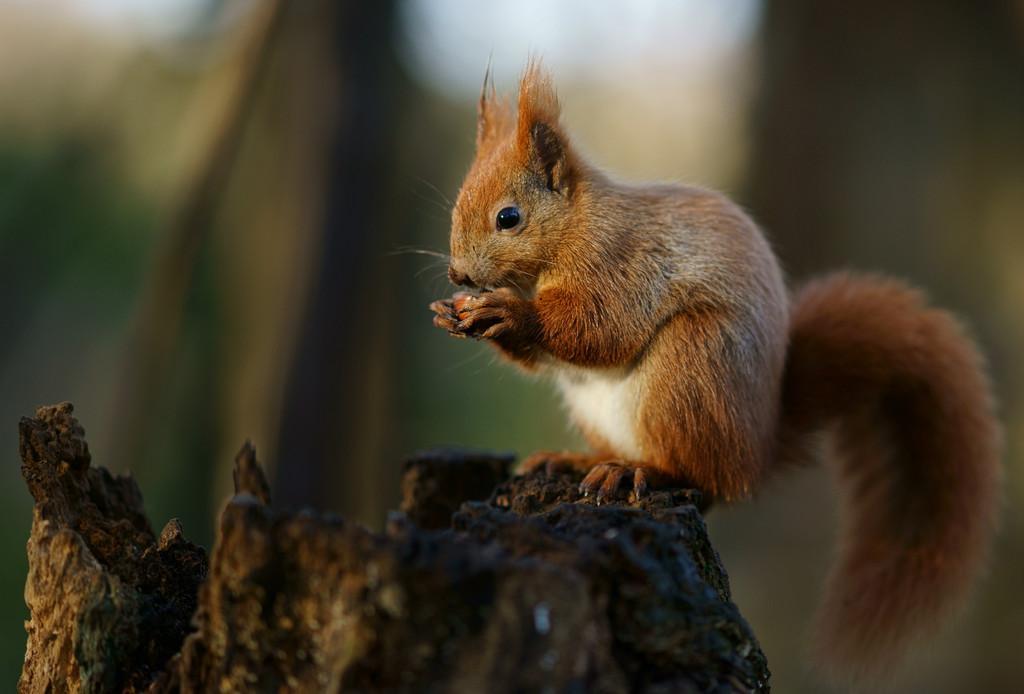In one or two sentences, can you explain what this image depicts? In this image I can see a squirrel sitting on the branch. The squirrel is in brown and white color. Background is blurred. 